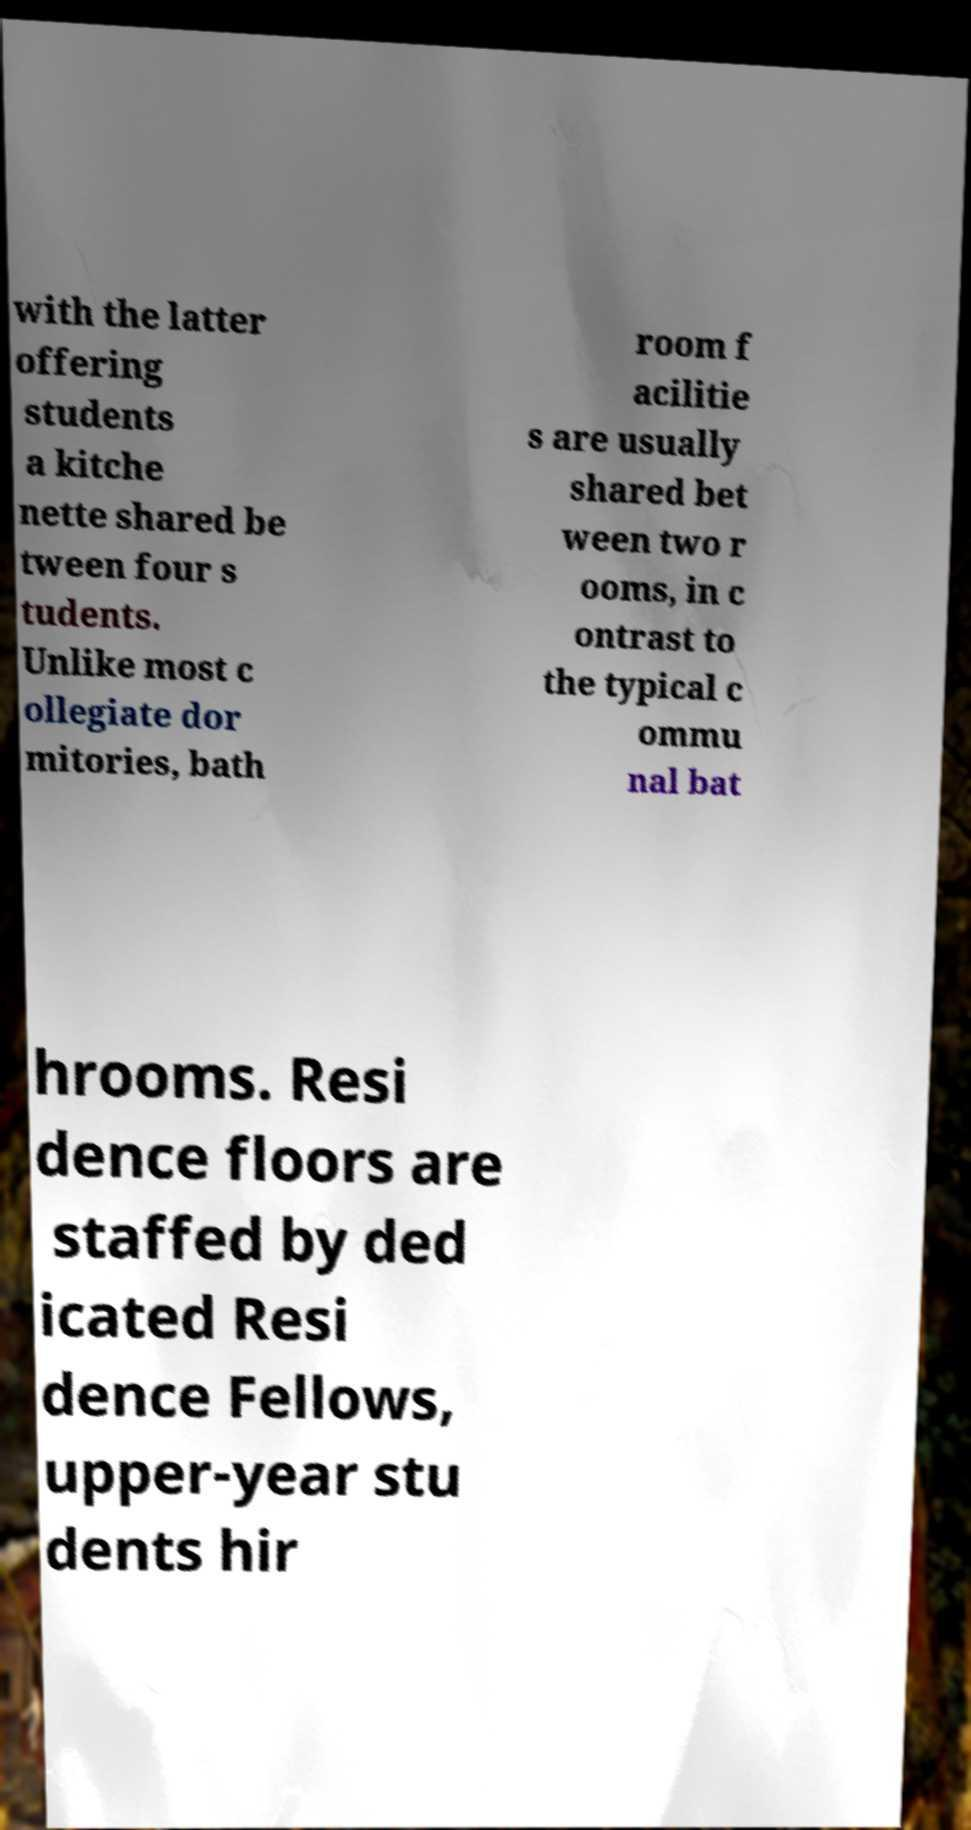Please identify and transcribe the text found in this image. with the latter offering students a kitche nette shared be tween four s tudents. Unlike most c ollegiate dor mitories, bath room f acilitie s are usually shared bet ween two r ooms, in c ontrast to the typical c ommu nal bat hrooms. Resi dence floors are staffed by ded icated Resi dence Fellows, upper-year stu dents hir 